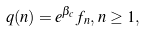<formula> <loc_0><loc_0><loc_500><loc_500>q ( n ) = e ^ { \beta _ { c } } f _ { n } , \, n \geq 1 ,</formula> 